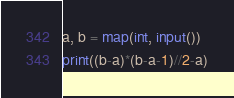<code> <loc_0><loc_0><loc_500><loc_500><_Python_>a, b = map(int, input())
print((b-a)*(b-a-1)//2-a)</code> 